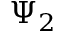Convert formula to latex. <formula><loc_0><loc_0><loc_500><loc_500>\Psi _ { 2 }</formula> 